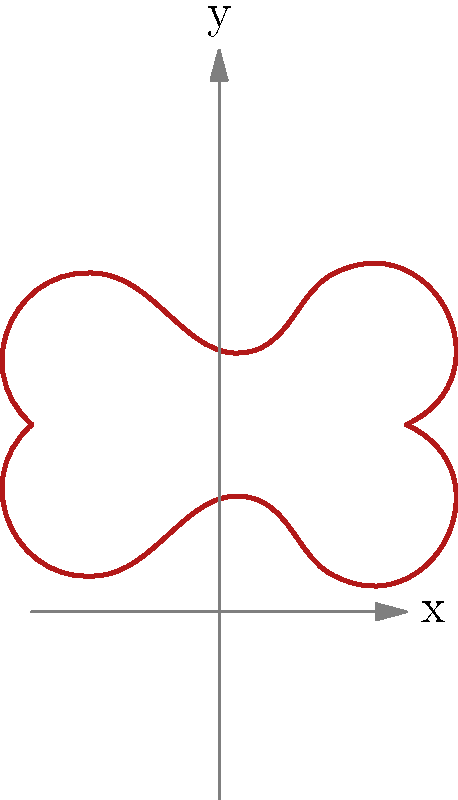In the diagram above, a stylized dragon wing is represented by the upper curve. The lower curve is obtained by reflecting the upper curve across the x-axis. Which geometric transformation would map the entire shape onto itself, preserving its orientation? To answer this question, we need to analyze the symmetry of the dragon wing shape:

1. The shape consists of two curves: the original wing and its reflection across the x-axis.

2. The reflection creates a symmetrical shape with respect to the x-axis.

3. However, the question asks for a transformation that preserves orientation, which rules out reflection.

4. Looking at the shape, we can see that if we rotate it 180° around the origin (0,0), it would map onto itself.

5. A 180° rotation is equivalent to a rotation by $\pi$ radians.

6. In geometric terms, this transformation is called a half-turn or point reflection about the origin.

7. Mathematically, this transformation can be represented by the matrix:
   $$\begin{pmatrix} -1 & 0 \\ 0 & -1 \end{pmatrix}$$

8. This transformation preserves the orientation of the shape while mapping it onto itself.

Therefore, the geometric transformation that maps the entire shape onto itself while preserving its orientation is a 180° rotation (or half-turn) about the origin.
Answer: 180° rotation about the origin 